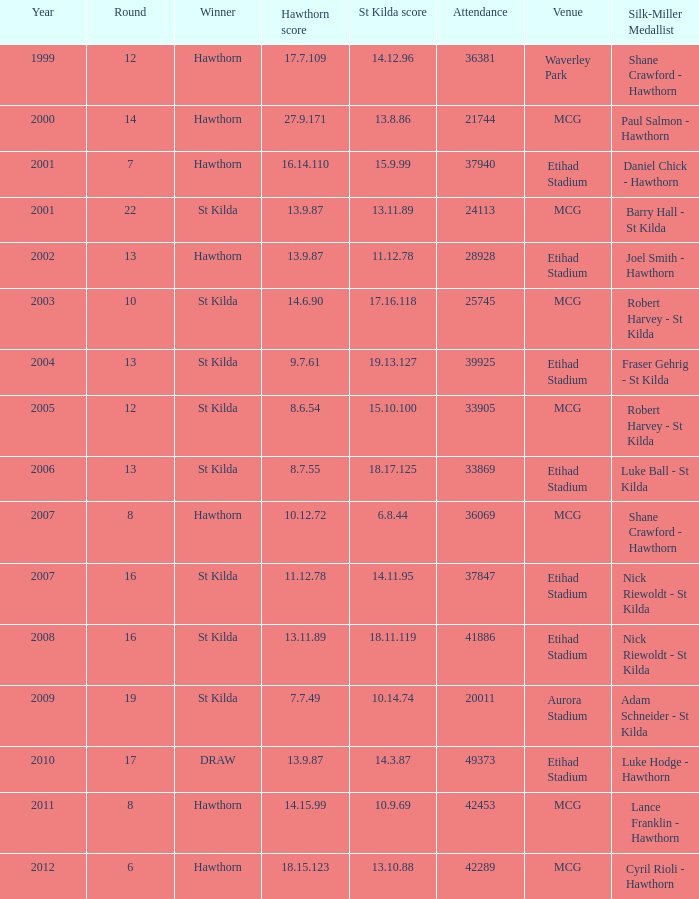123? 42289.0. 